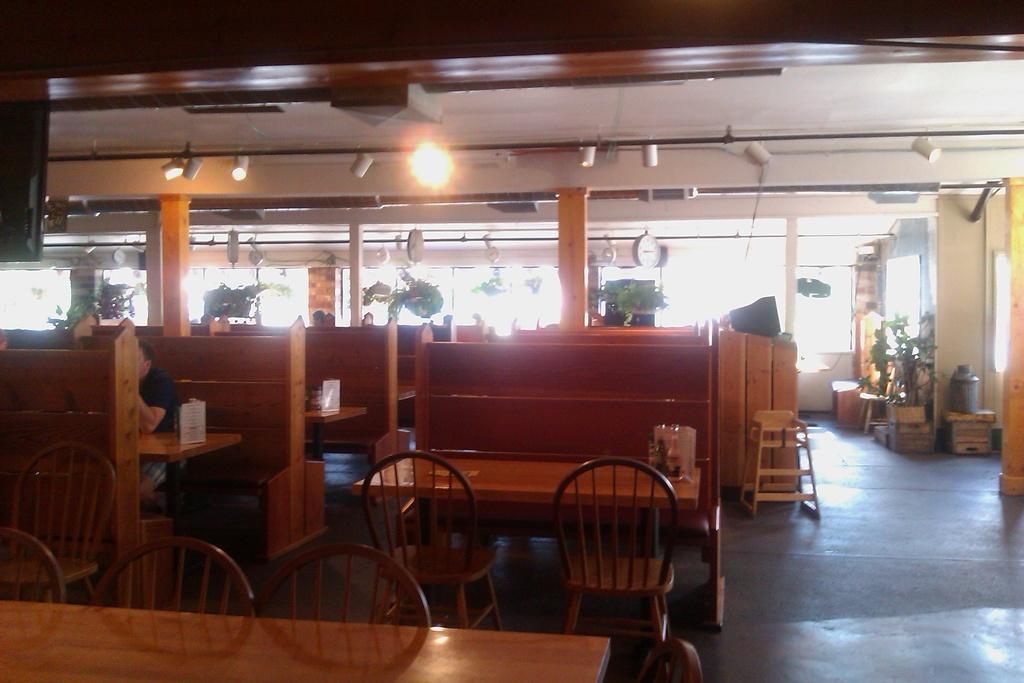Please provide a concise description of this image. In this picture there are tables and chairs in the center of the image and there are lamps on the roof at the top side of the image, there are plant pots in the image and there is a person who is sitting on the left side of the image. 